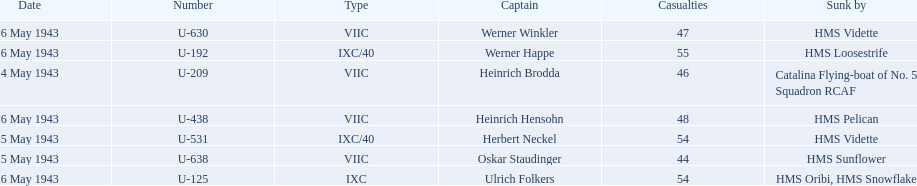Which sunken u-boat had the most casualties U-192. 